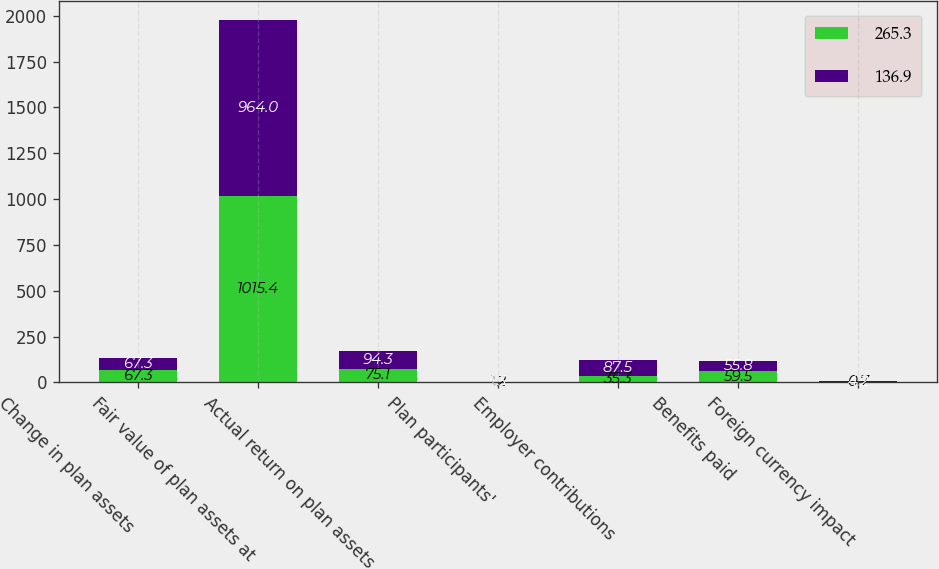<chart> <loc_0><loc_0><loc_500><loc_500><stacked_bar_chart><ecel><fcel>Change in plan assets<fcel>Fair value of plan assets at<fcel>Actual return on plan assets<fcel>Plan participants'<fcel>Employer contributions<fcel>Benefits paid<fcel>Foreign currency impact<nl><fcel>265.3<fcel>67.3<fcel>1015.4<fcel>75.1<fcel>1.2<fcel>35.3<fcel>59.5<fcel>0.7<nl><fcel>136.9<fcel>67.3<fcel>964<fcel>94.3<fcel>1.3<fcel>87.5<fcel>55.8<fcel>4.2<nl></chart> 